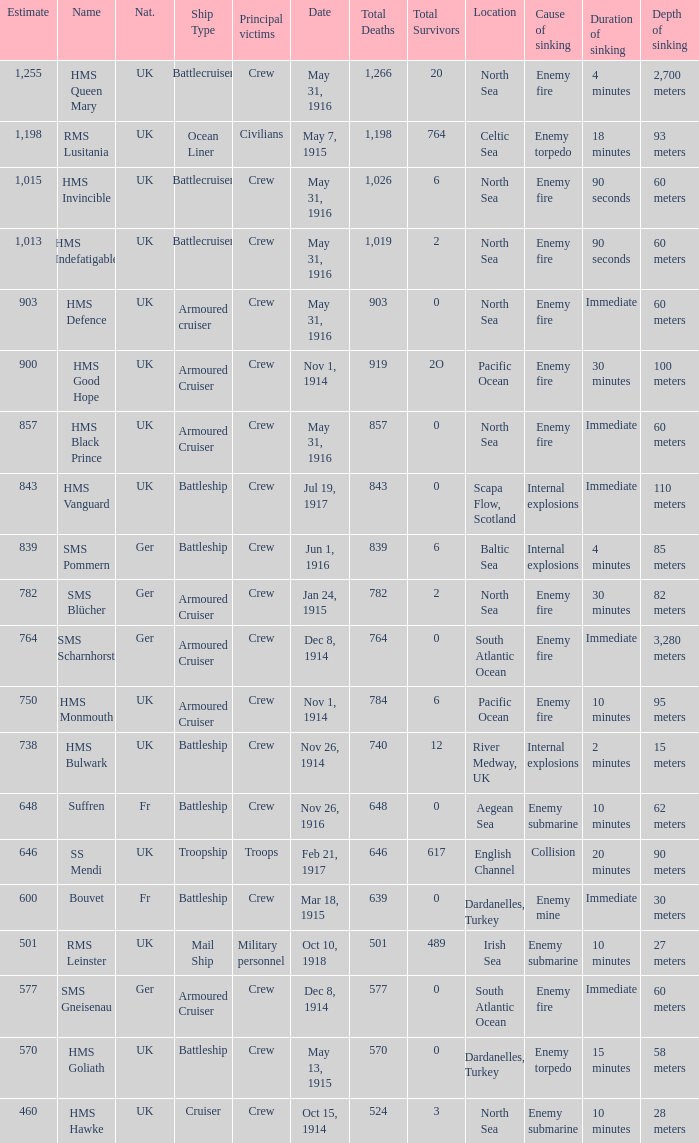What is the name of the battleship with the battle listed on may 13, 1915? HMS Goliath. 